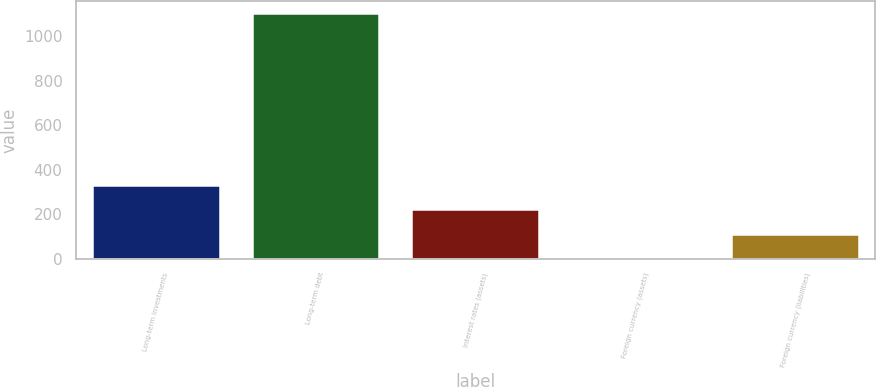Convert chart to OTSL. <chart><loc_0><loc_0><loc_500><loc_500><bar_chart><fcel>Long-term investments<fcel>Long-term debt<fcel>Interest rates (assets)<fcel>Foreign currency (assets)<fcel>Foreign currency (liabilities)<nl><fcel>331.49<fcel>1102.4<fcel>221.36<fcel>1.1<fcel>111.23<nl></chart> 